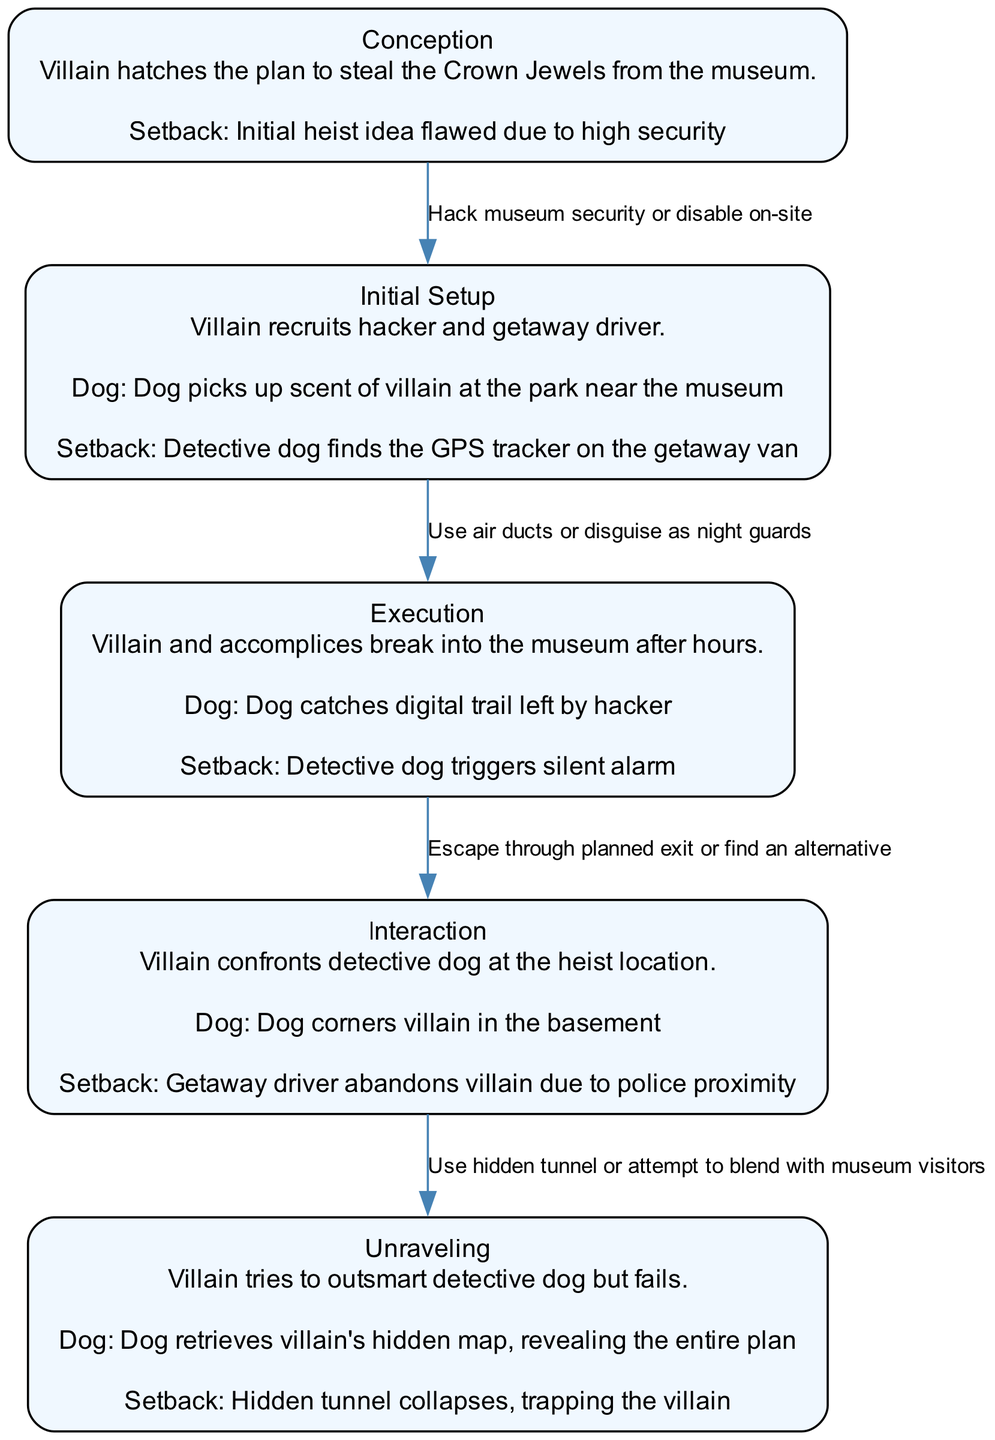What is the first stage in the villain's plan development? The diagram lists "Conception" as the first stage, which is clearly highlighted.
Answer: Conception How many setbacks are mentioned in the entire clinical pathway? By reviewing each stage in the diagram, there are a total of five setbacks, one for each stage.
Answer: 5 What decision point does the villain face during the Execution stage? The decision point listed in the Execution stage is whether to use air ducts or disguise as night guards.
Answer: Use air ducts or disguise as night guards Which stage includes an interaction between the villain and the detective dog? The Interaction stage explicitly describes a confrontation between the villain and the detective dog, making it the relevant stage.
Answer: Interaction What setback occurs when the villain executes their plan? The setback mentioned during the Execution stage is that the detective dog triggers a silent alarm.
Answer: Detective dog triggers silent alarm What does the villain try to do during the Unraveling stage? In the Unraveling stage, the villain tries to outsmart the detective dog, indicating their attempt to escape or evade capture.
Answer: Outsmart detective dog What decision point is presented in the Unraveling stage? The decision point in the Unraveling stage is whether to use a hidden tunnel or attempt to blend with museum visitors.
Answer: Use hidden tunnel or attempt to blend with museum visitors At what stage does the villain face police proximity? The setback involving police proximity is noted in the Interaction stage when the getaway driver abandons the villain.
Answer: Interaction Which stage allows the detective dog to retrieve a hidden map? The Unraveling stage mentions that the dog retrieves the villain's hidden map, revealing the entire plan, linking this stage to the dog's successful intervention.
Answer: Unraveling 